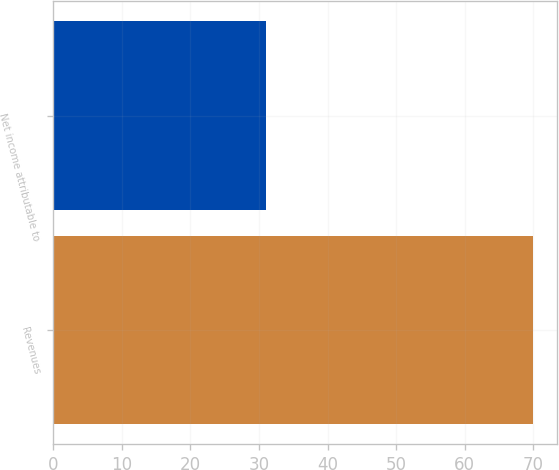<chart> <loc_0><loc_0><loc_500><loc_500><bar_chart><fcel>Revenues<fcel>Net income attributable to<nl><fcel>70<fcel>31<nl></chart> 